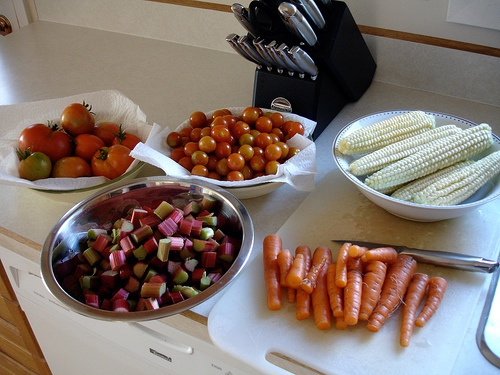Describe the objects in this image and their specific colors. I can see bowl in gray, black, maroon, and darkgray tones, bowl in gray, darkgray, lightgray, and olive tones, bowl in gray, maroon, brown, lavender, and darkgray tones, carrot in gray, brown, and maroon tones, and carrot in gray, brown, and maroon tones in this image. 